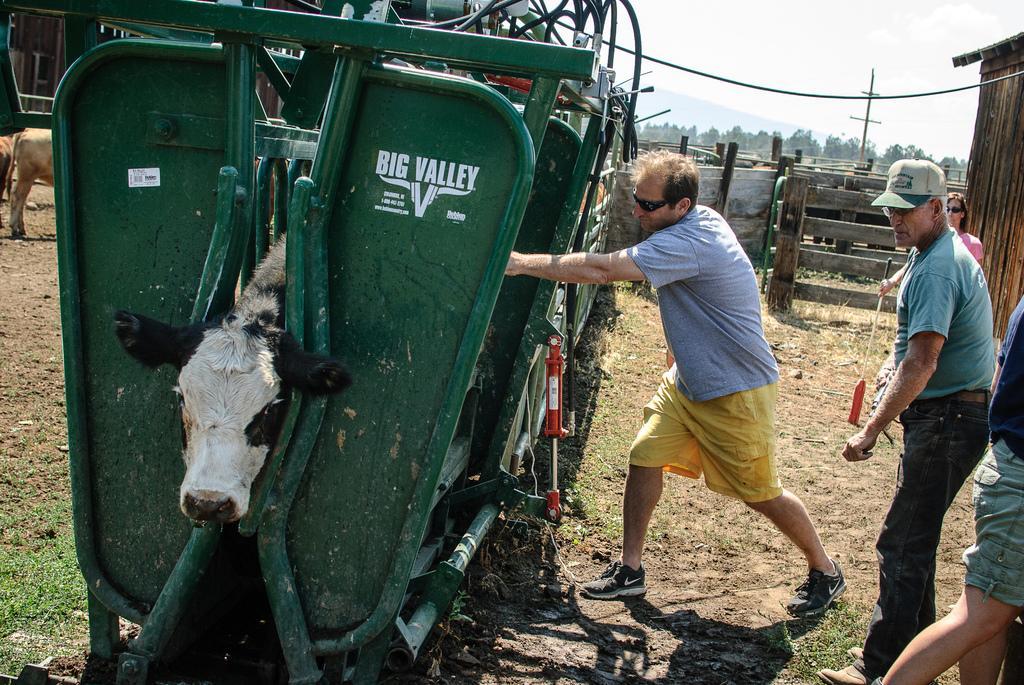Please provide a concise description of this image. In this image we can see a group of people standing on the ground. One woman is holding a stick in her hand. On the left side of the image we can see some animal on the ground. One animal is inside a metal frame containing some pipes and cables. In the background, we can see a fence, shed, a pole, hill and group of trees. At the top of the image we can see the sky. 